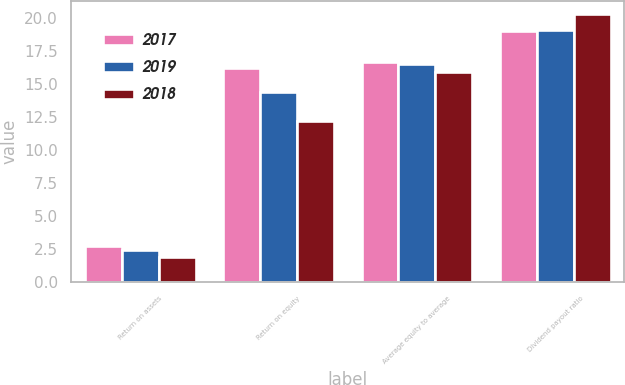Convert chart to OTSL. <chart><loc_0><loc_0><loc_500><loc_500><stacked_bar_chart><ecel><fcel>Return on assets<fcel>Return on equity<fcel>Average equity to average<fcel>Dividend payout ratio<nl><fcel>2017<fcel>2.7<fcel>16.2<fcel>16.7<fcel>19<nl><fcel>2019<fcel>2.4<fcel>14.4<fcel>16.5<fcel>19.1<nl><fcel>2018<fcel>1.9<fcel>12.2<fcel>15.9<fcel>20.3<nl></chart> 